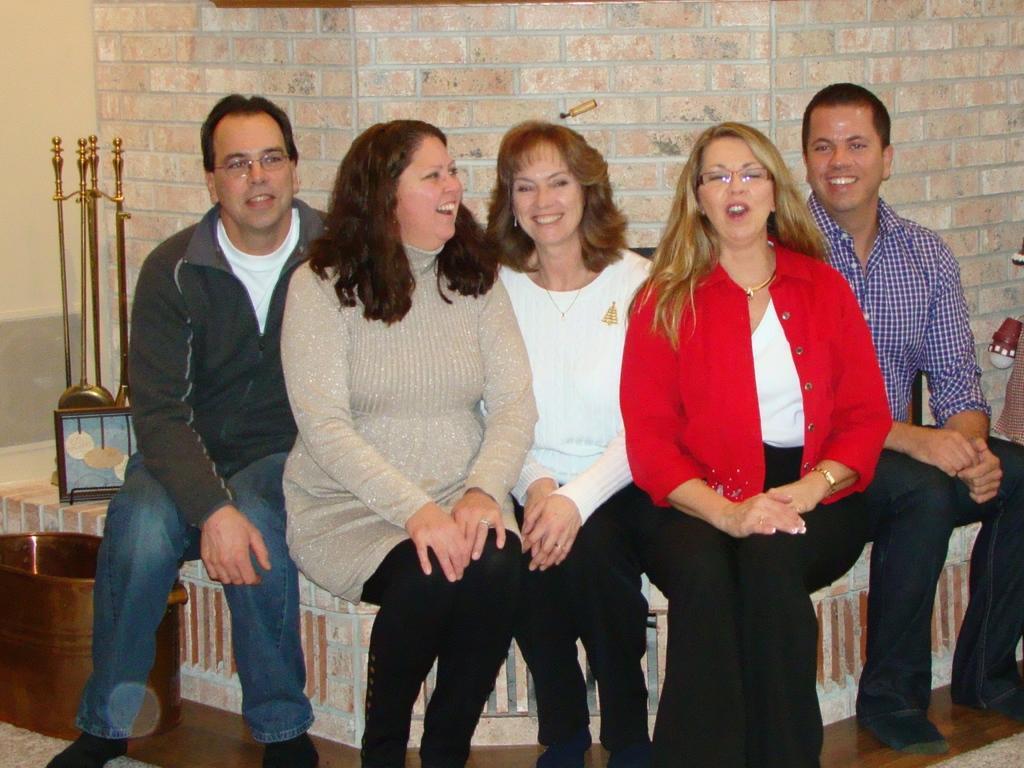Please provide a concise description of this image. In this image I can see there are five persons and there are smiling and sitting in front of the wall and I can see a stand on the left side and I can see a container kept in front of the wall on the left side. 